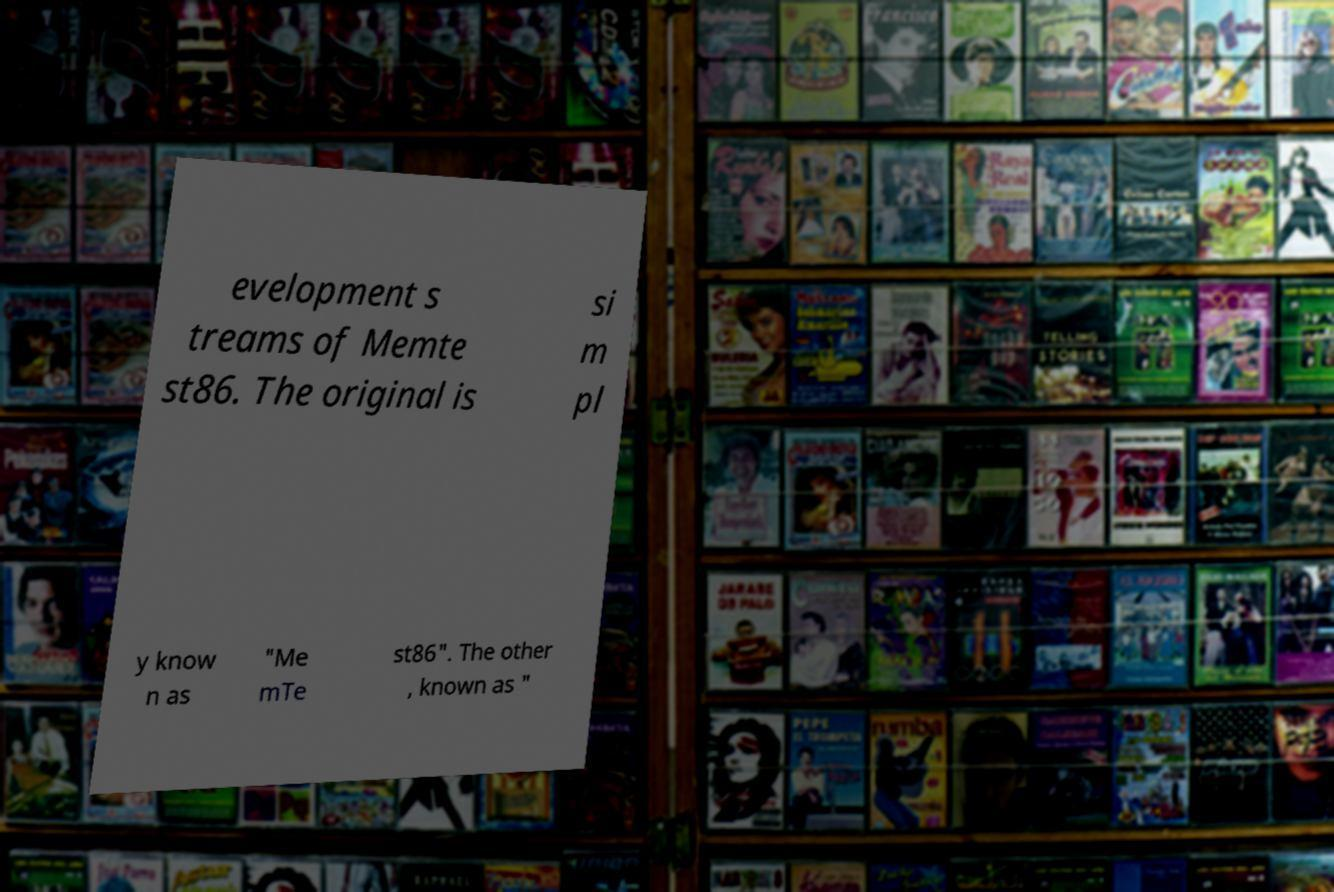Please read and relay the text visible in this image. What does it say? evelopment s treams of Memte st86. The original is si m pl y know n as "Me mTe st86". The other , known as " 